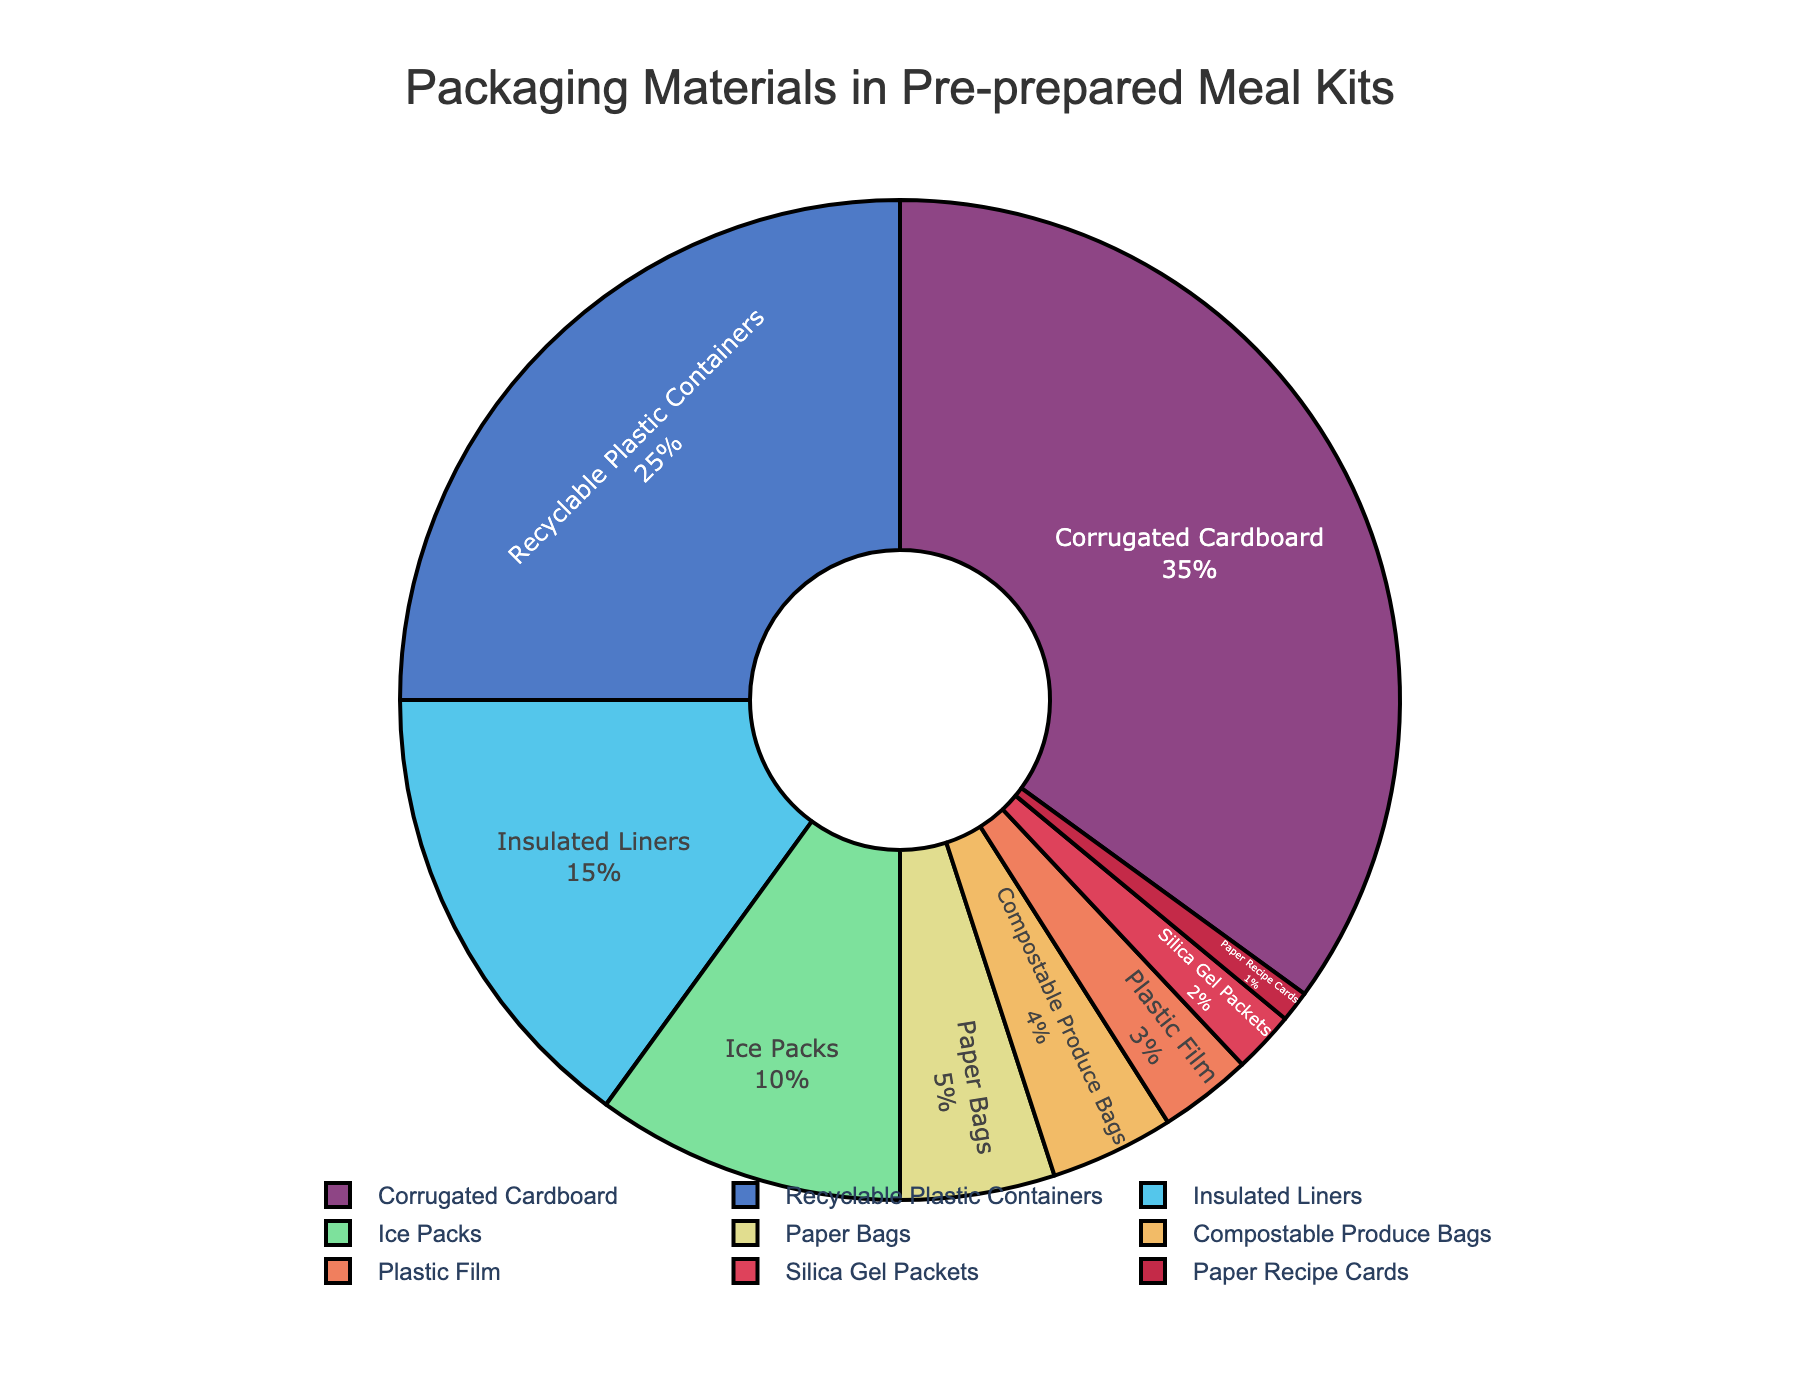What's the most common packaging material used? The largest segment of the pie chart represents the most common packaging material. The "Corrugated Cardboard" segment is the largest, indicating it's the most common material.
Answer: Corrugated Cardboard What's the combined percentage of recyclable plastic containers and insulated liners? Sum the percentages of "Recyclable Plastic Containers" and "Insulated Liners", which are 25% and 15%, respectively. 25 + 15 equals 40.
Answer: 40% Which packaging material has the smallest percentage? The smallest segment on the pie chart indicates the material with the smallest percentage, which is "Paper Recipe Cards" at 1%.
Answer: Paper Recipe Cards Are there more paper-based or plastic-based materials, and by how much? Sum the percentages of paper-based materials (Corrugated Cardboard, Paper Bags, Paper Recipe Cards) and plastic-based materials (Recyclable Plastic Containers, Plastic Film). Paper-based: 35 + 5 + 1 = 41%. Plastic-based: 25 + 3 = 28%. Paper-based materials are more by 41 - 28 = 13%.
Answer: Paper-based by 13% What percentage of the packaging materials is dedicated to items related to temperature control (insulated liners and ice packs)? Sum the percentages of "Insulated Liners" and "Ice Packs", which are 15% and 10%, respectively. 15 + 10 = 25%.
Answer: 25% Which is more abundant, compostable produce bags or plastic film? By how much? Compare the percentages of "Compostable Produce Bags" (4%) and "Plastic Film" (3%). Compostable produce bags are more than plastic film by 4 - 3 = 1%.
Answer: Compostable produce bags by 1% If you combine the percentages of the three smallest materials, what is the total? Sum the percentages of the three smallest materials: "Plastic Film" (3%), "Silica Gel Packets" (2%), "Paper Recipe Cards" (1%). 3 + 2 + 1 = 6%.
Answer: 6% How much more common is corrugated cardboard compared to the second most common material? Subtract the percentage of the second most common material ("Recyclable Plastic Containers" at 25%) from the most common material ("Corrugated Cardboard" at 35%). 35 - 25 = 10%.
Answer: 10% What's the difference in percentage between the insulated liners and paper bags? Subtract the percentage of "Paper Bags" (5%) from "Insulated Liners" (15%). 15 - 5 = 10%.
Answer: 10% Among the listed materials, which covers more percentage: ice packs or the combined percentage of compostable produce bags and paper recipe cards? Compare "Ice Packs" (10%) and the combined percentage of "Compostable Produce Bags" (4%) and "Paper Recipe Cards" (1%). 4 + 1 = 5%. Ice packs cover more since 10% > 5%.
Answer: Ice Packs 